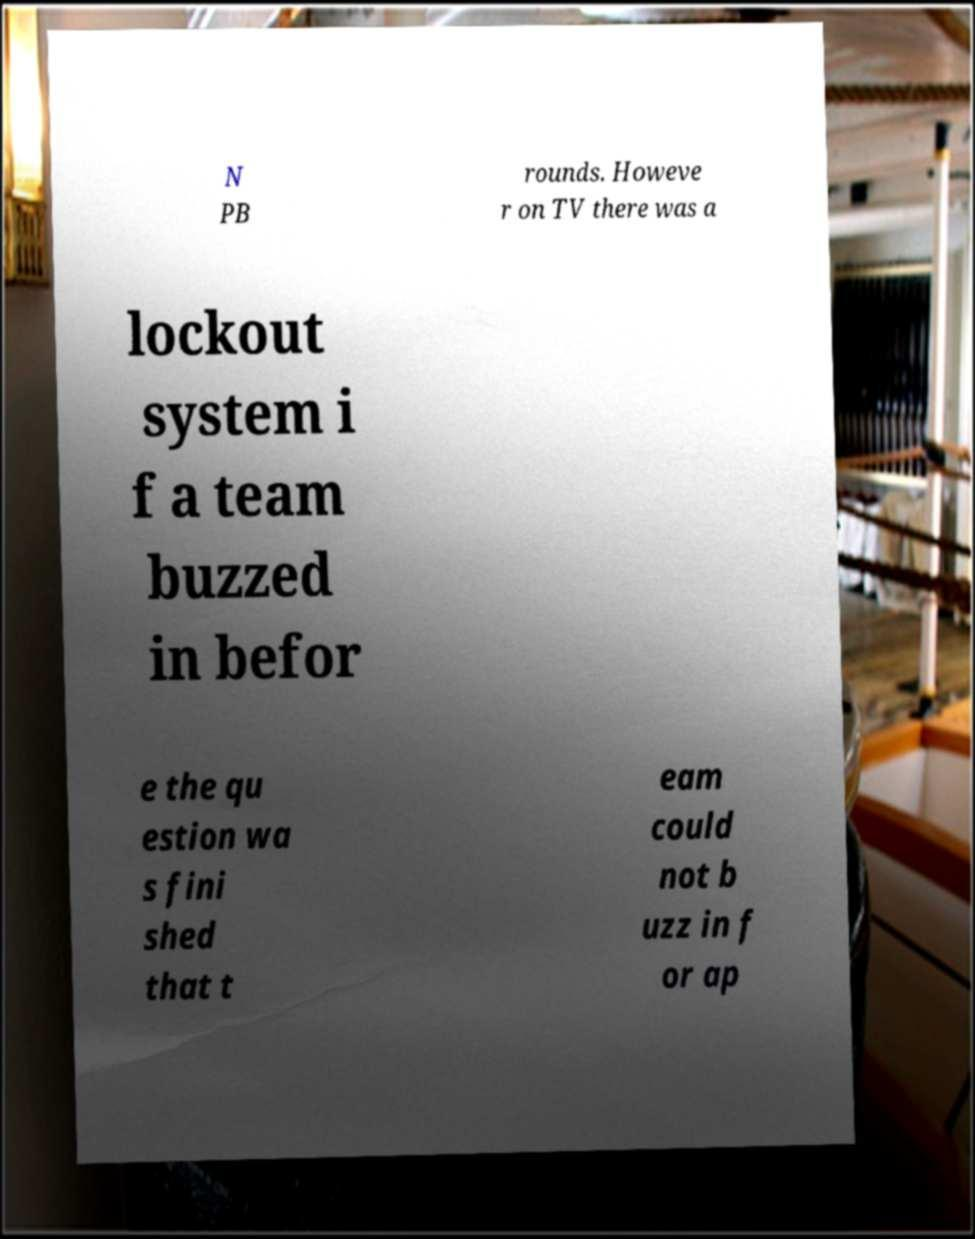Can you accurately transcribe the text from the provided image for me? N PB rounds. Howeve r on TV there was a lockout system i f a team buzzed in befor e the qu estion wa s fini shed that t eam could not b uzz in f or ap 